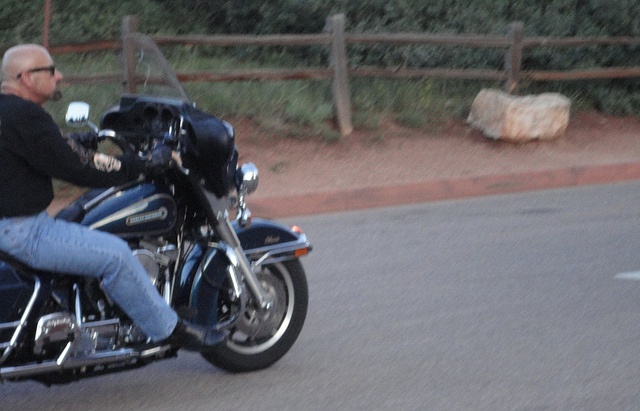Describe the objects in this image and their specific colors. I can see motorcycle in black and gray tones and people in black and gray tones in this image. 